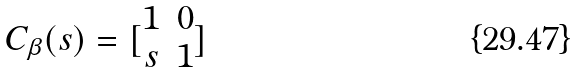<formula> <loc_0><loc_0><loc_500><loc_500>C _ { \beta } ( s ) = [ \begin{matrix} 1 & 0 \\ s & 1 \end{matrix} ]</formula> 